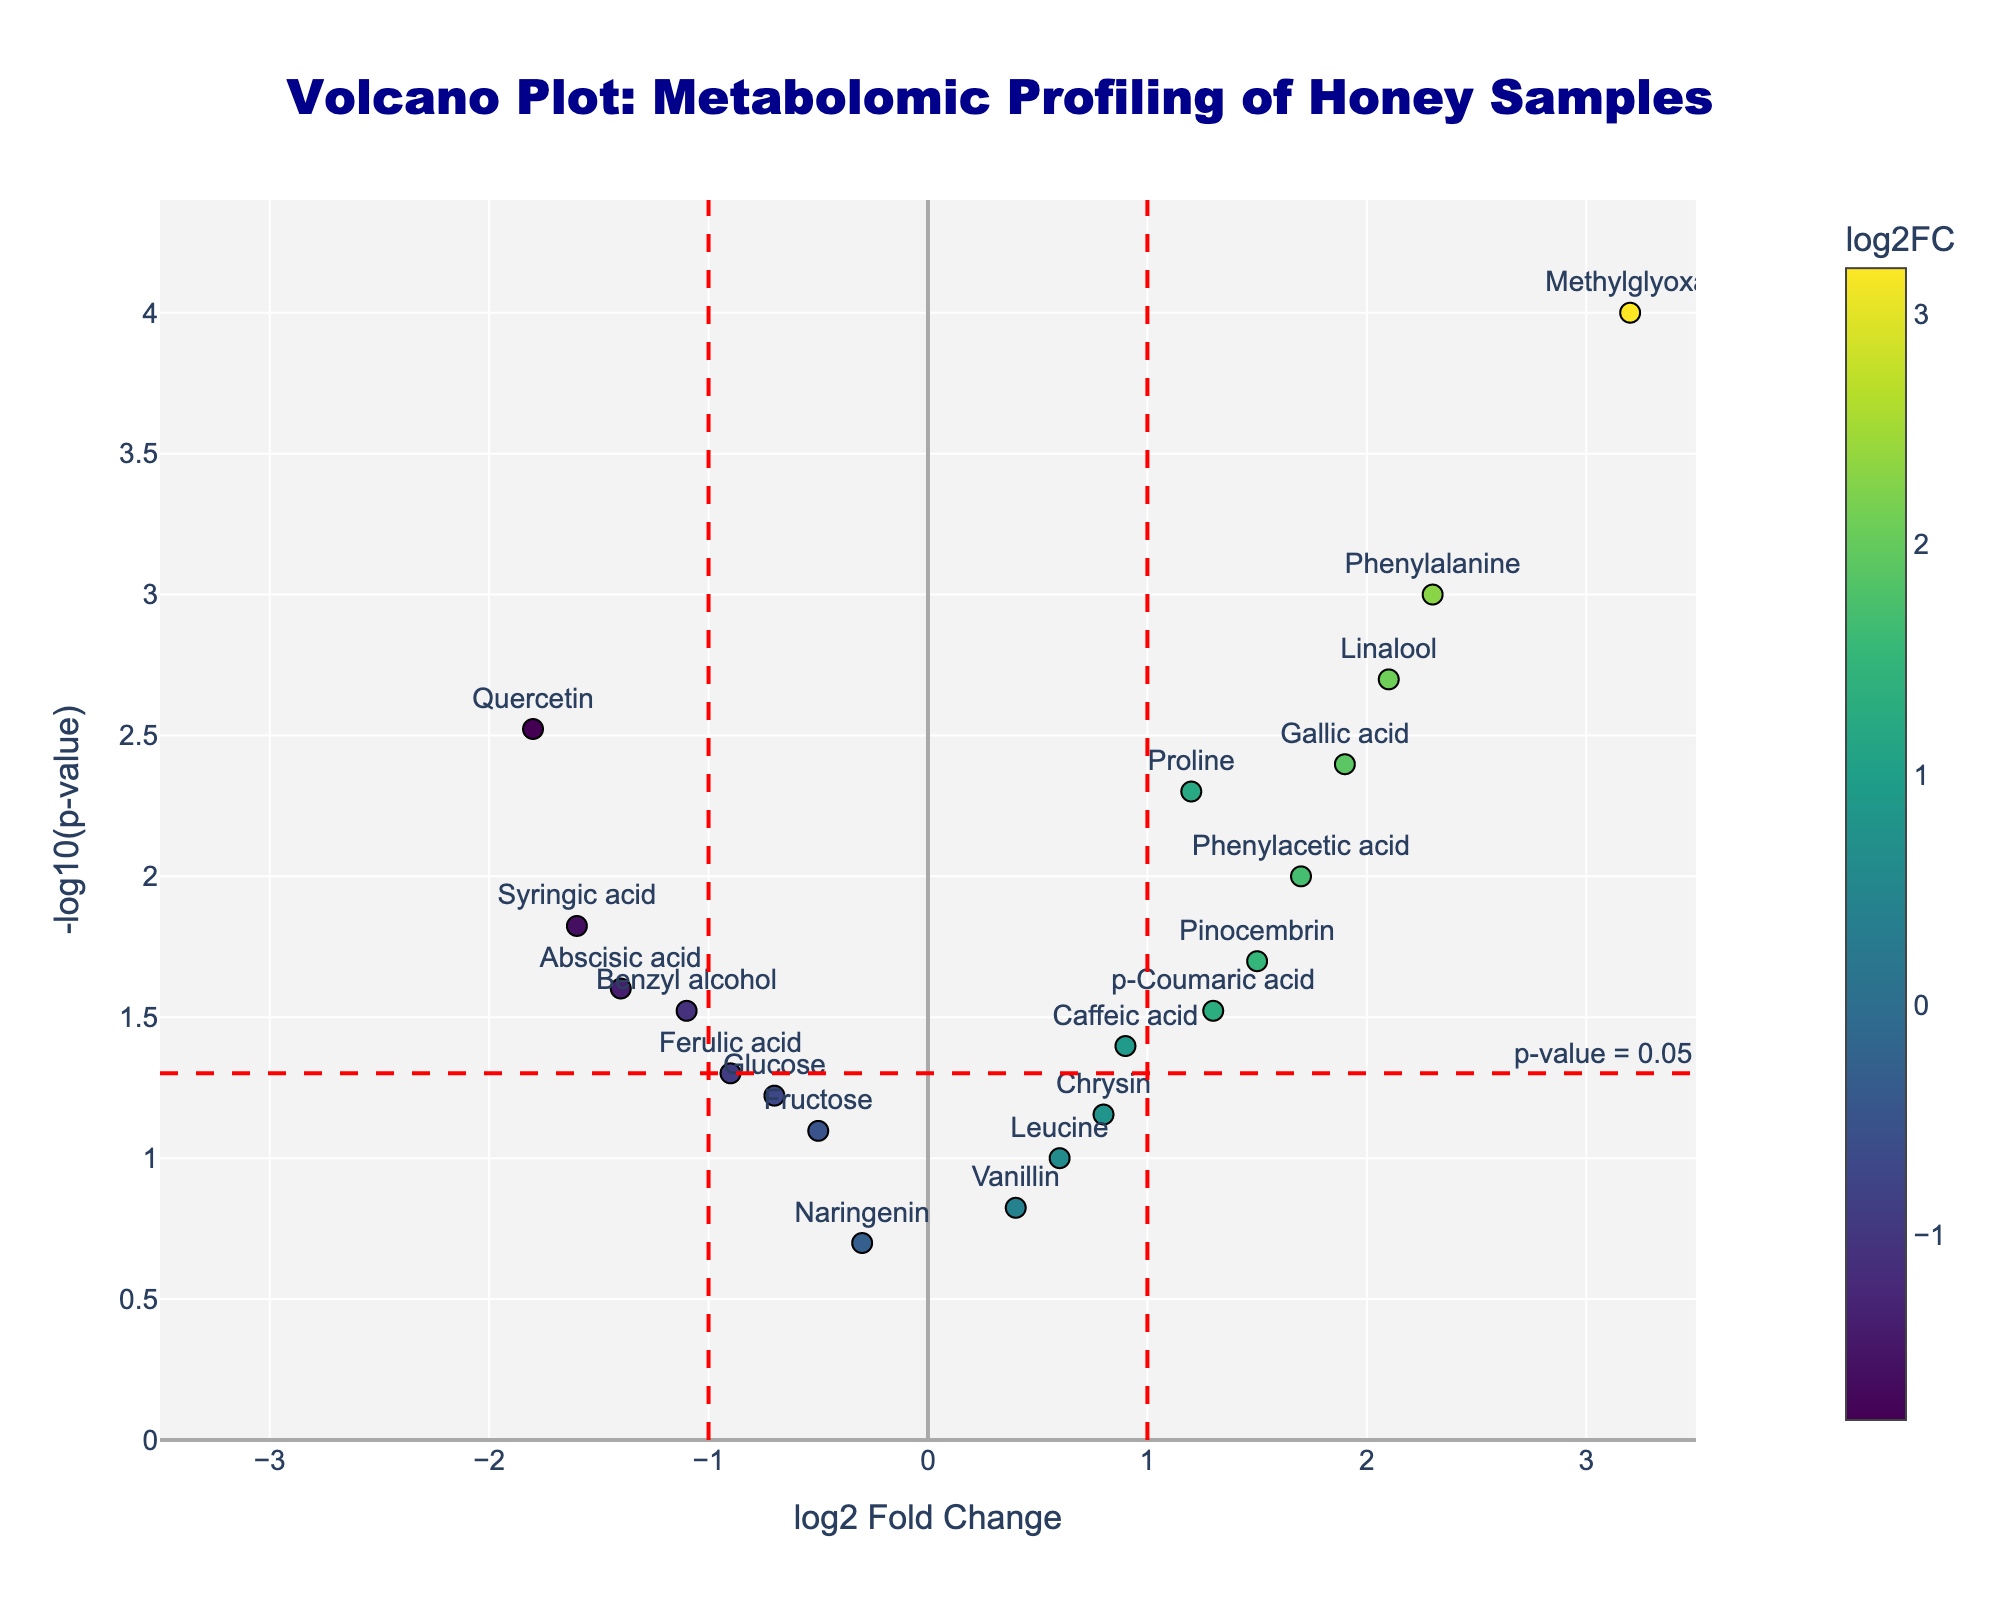What is the title of the volcano plot? The title of the plot is displayed prominently at the top and reads "Volcano Plot: Metabolomic Profiling of Honey Samples".
Answer: Volcano Plot: Metabolomic Profiling of Honey Samples How many compounds have a p-value below 0.05? To determine how many compounds have a p-value below 0.05, we look for data points above the horizontal red dashed line, which represents -log10(0.05). By counting these points, we see there are 13 compounds.
Answer: 13 Which compound shows the highest log2 fold change? The compound with the highest log2 fold change can be identified by finding the data point farthest to the right. According to the hover text, "Methylglyoxal" has the highest log2FC of 3.2.
Answer: Methylglyoxal What is the log2 fold change value for Quercetin? The log2 fold change value for Quercetin can be found by locating its marker on the plot or by checking its hover text. Its log2FC value is -1.8.
Answer: -1.8 Which compounds have a log2 fold change greater than 1 and a p-value less than 0.05? Compounds with a log2 fold change greater than 1 are on the right side of the vertical red dashed line at x=1. Compounds with a p-value less than 0.05 are above the horizontal red dashed line. The compounds meeting both criteria are "Phenylalanine," "Linalool," "Methylglyoxal," and "Phenylacetic acid."
Answer: Phenylalanine, Linalool, Methylglyoxal, Phenylacetic acid What is the overall distribution of p-values in terms of -log10(p-value)? The overall distribution of p-values is visualized by the y-axis values. Most data points are clustered between -log10(p-value) of 1 and 3, indicating most p-values range approximately from 0.1 to 0.001.
Answer: Between 1 and 3 Which compound has the smallest p-value and what is its log2 fold change? The compound with the smallest p-value will have the highest -log10(p-value) on the y-axis. "Methylglyoxal" has the smallest p-value as indicated by its highest position on the y-axis, with a log2 fold change of 3.2.
Answer: Methylglyoxal, 3.2 How many compounds have a negative log2 fold change but a p-value less than 0.05? Negative log2 fold change compounds are on the left side of the vertical red dashed line at x=-1. Compounds with a p-value less than 0.05 are above the horizontal red dashed line. Counting these points, we identify "Quercetin," "Benzyl alcohol," "Abscisic acid," and "Syringic acid."
Answer: 4 Which compound is nearest to the origin in the plot? The compound nearest to the origin (0,0) has the smallest absolute values for both log2 fold change and -log10(p-value). "Naringenin" is closest to the origin with log2FC of -0.3 and a corresponding low -log10(p-value).
Answer: Naringenin 